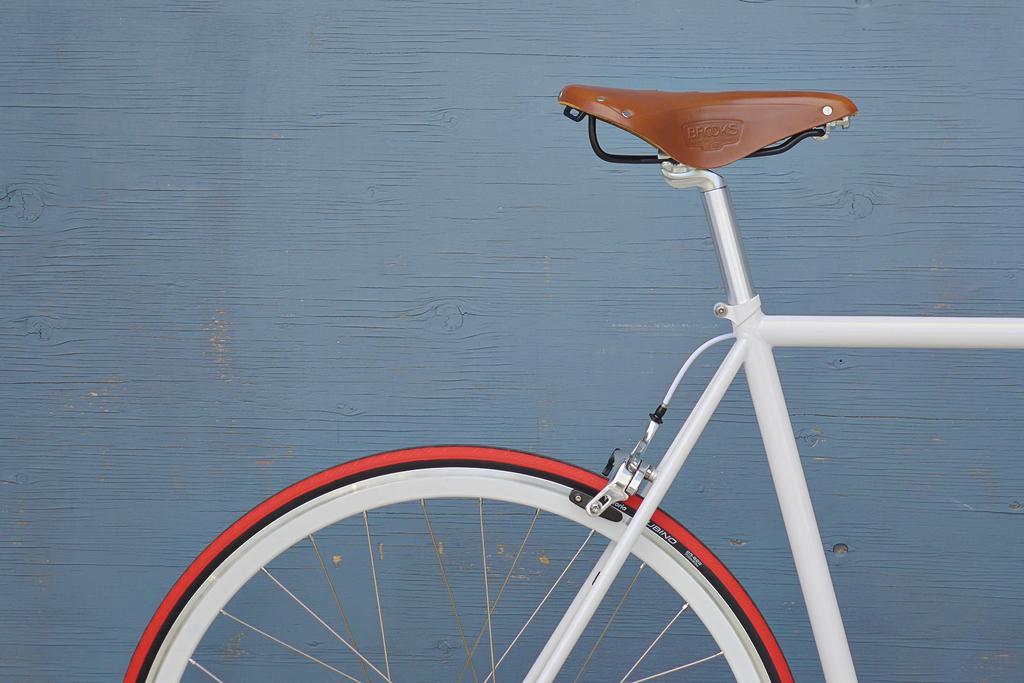In one or two sentences, can you explain what this image depicts? In this image in the front there is a bicycle. In the background there is a wall. 